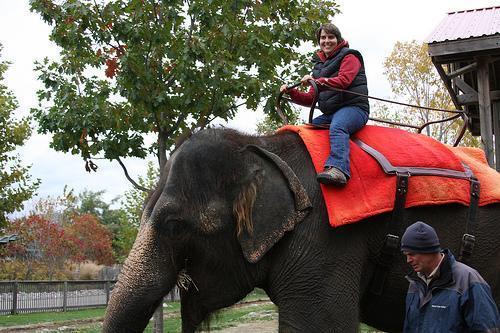How many people are there?
Give a very brief answer. 2. 